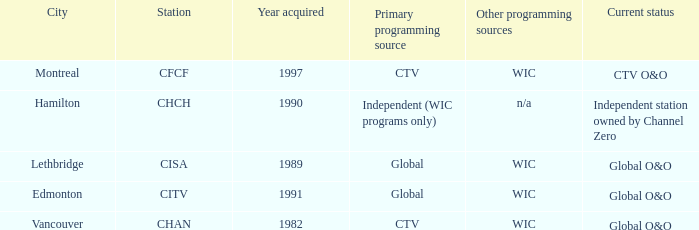How any were gained as the chan 1.0. 